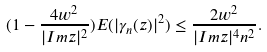<formula> <loc_0><loc_0><loc_500><loc_500>( 1 - \frac { 4 w ^ { 2 } } { | I m z | ^ { 2 } } ) E ( | \gamma _ { n } ( z ) | ^ { 2 } ) \leq \frac { 2 w ^ { 2 } } { | I m z | ^ { 4 } n ^ { 2 } } .</formula> 